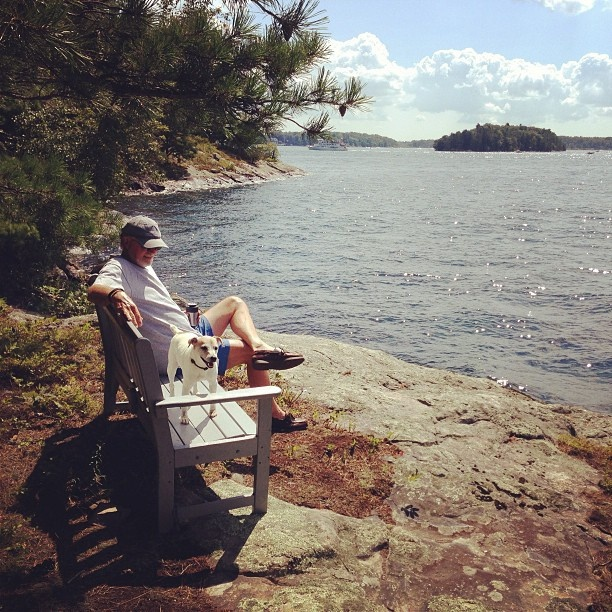Describe the objects in this image and their specific colors. I can see bench in black, gray, and beige tones, people in black, gray, ivory, and darkgray tones, dog in black, tan, and beige tones, and cup in black, gray, and darkgray tones in this image. 